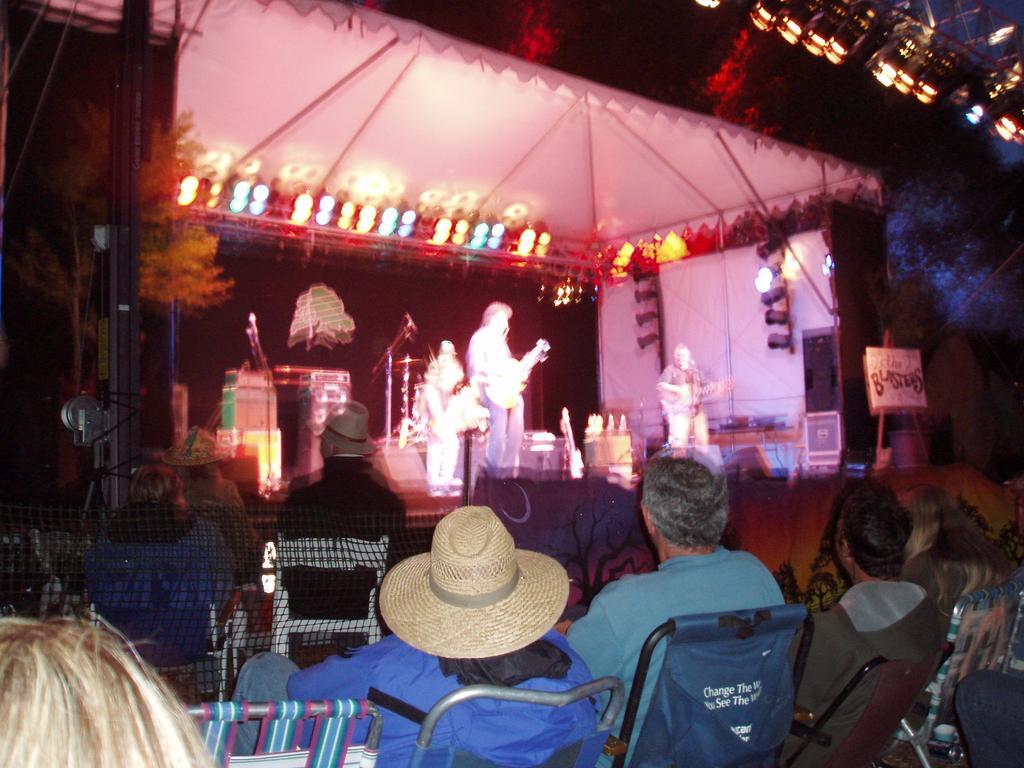How would you summarize this image in a sentence or two? In this picture there are few persons playing music instruments on the stage and there are few audience sitting in front of them. 